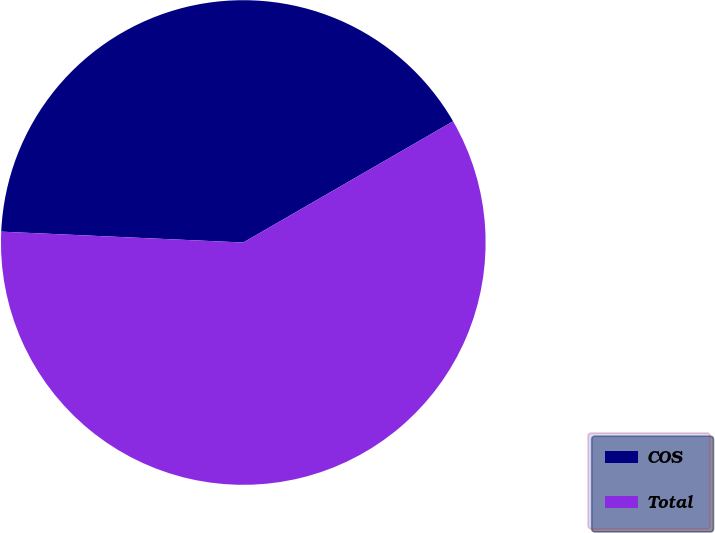Convert chart. <chart><loc_0><loc_0><loc_500><loc_500><pie_chart><fcel>COS<fcel>Total<nl><fcel>40.95%<fcel>59.05%<nl></chart> 